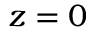<formula> <loc_0><loc_0><loc_500><loc_500>z = 0</formula> 